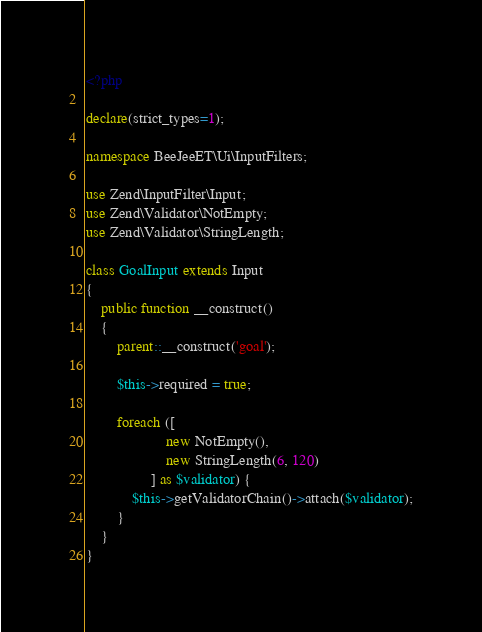Convert code to text. <code><loc_0><loc_0><loc_500><loc_500><_PHP_><?php

declare(strict_types=1);

namespace BeeJeeET\Ui\InputFilters;

use Zend\InputFilter\Input;
use Zend\Validator\NotEmpty;
use Zend\Validator\StringLength;

class GoalInput extends Input
{
    public function __construct()
    {
        parent::__construct('goal');

        $this->required = true;

        foreach ([
                     new NotEmpty(),
                     new StringLength(6, 120)
                 ] as $validator) {
            $this->getValidatorChain()->attach($validator);
        }
    }
}
</code> 